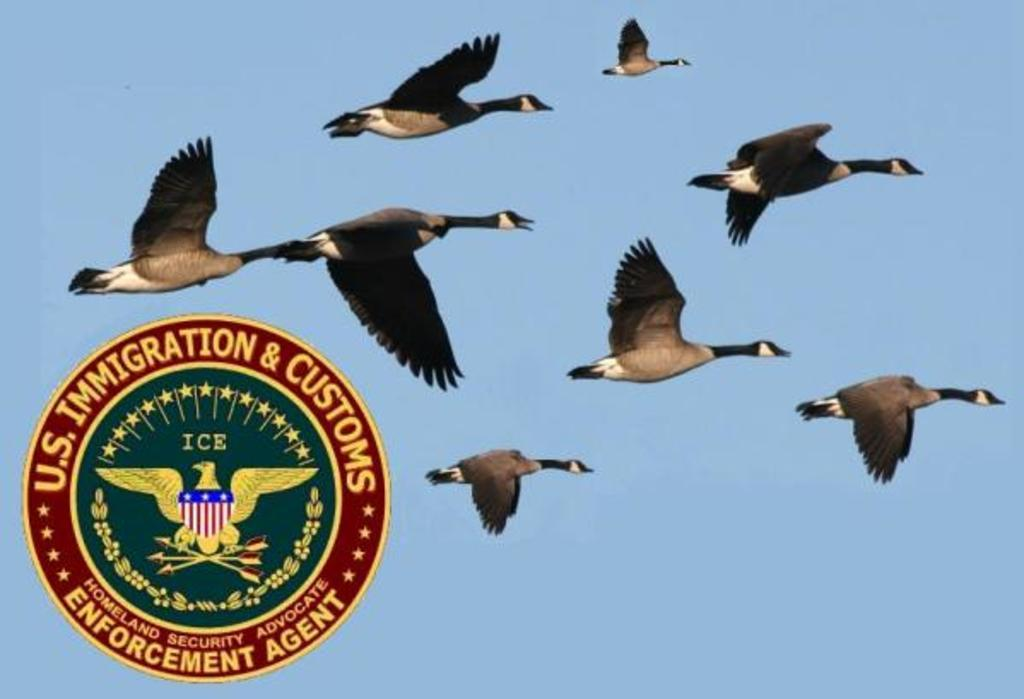What is happening in the center of the picture? There are birds flying in the center of the picture. What can be seen on the left side of the image? There is a logo on the left side of the image. How would you describe the weather in the image? The sky is sunny, indicating a clear and bright day. How many kittens are playing with a quince in the image? There are no kittens or quince present in the image. 